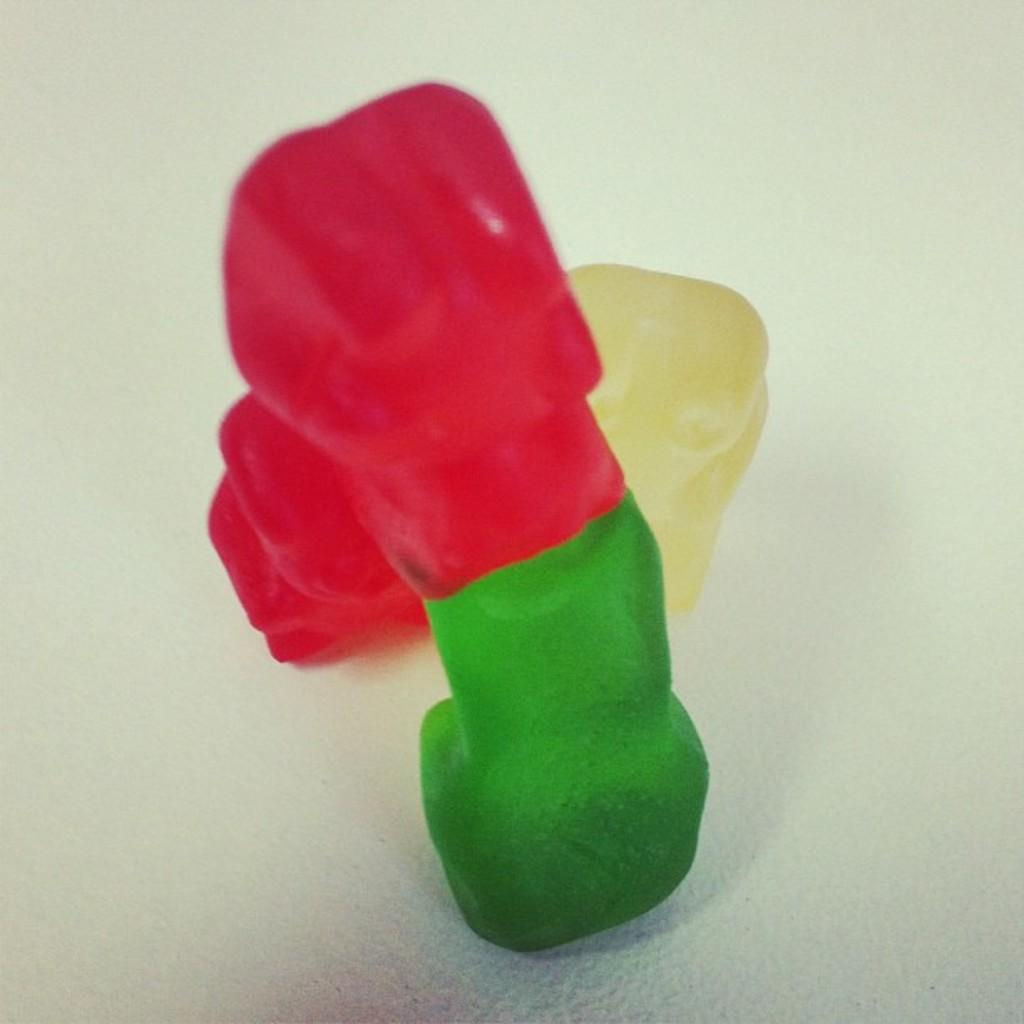What type of objects are in the foreground of the image? There are candies in the foreground of the image. What is the color of the surface on which the candies are placed? The candies are on a white surface. What type of advice can be seen written on the door in the image? There is no door present in the image, and therefore no advice can be seen written on it. 